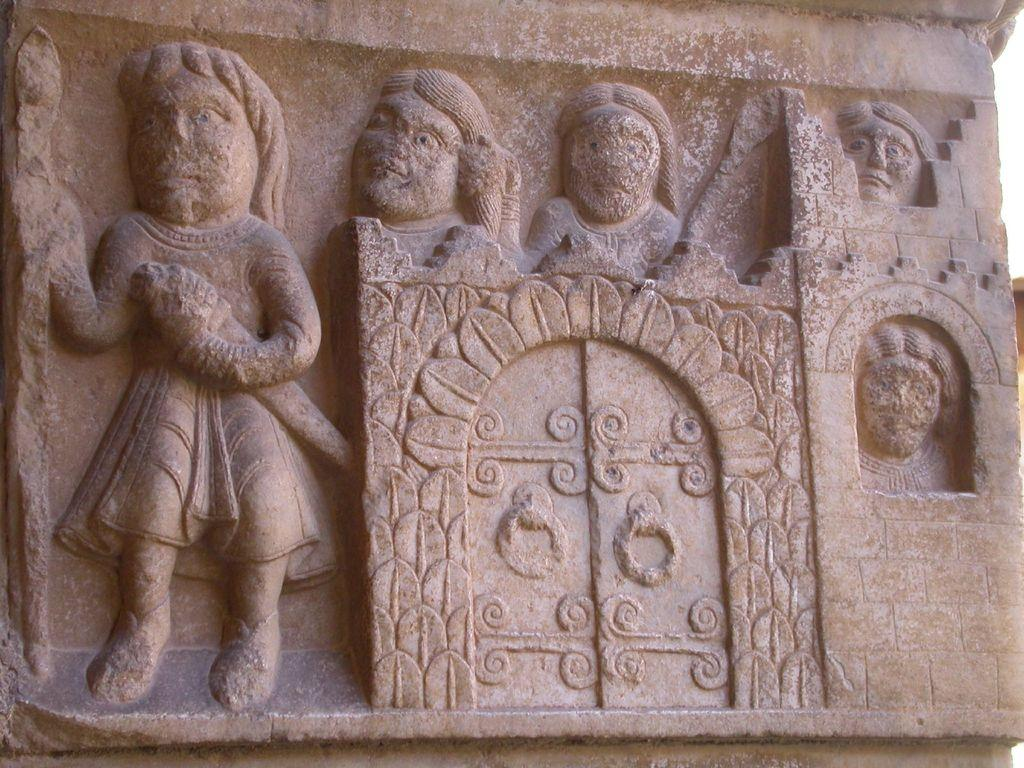What is on the wall in the image? There is a sculpture on the wall in the image. What type of cloth is being discussed in the image? There is no cloth or discussion present in the image; it features a sculpture on the wall. 